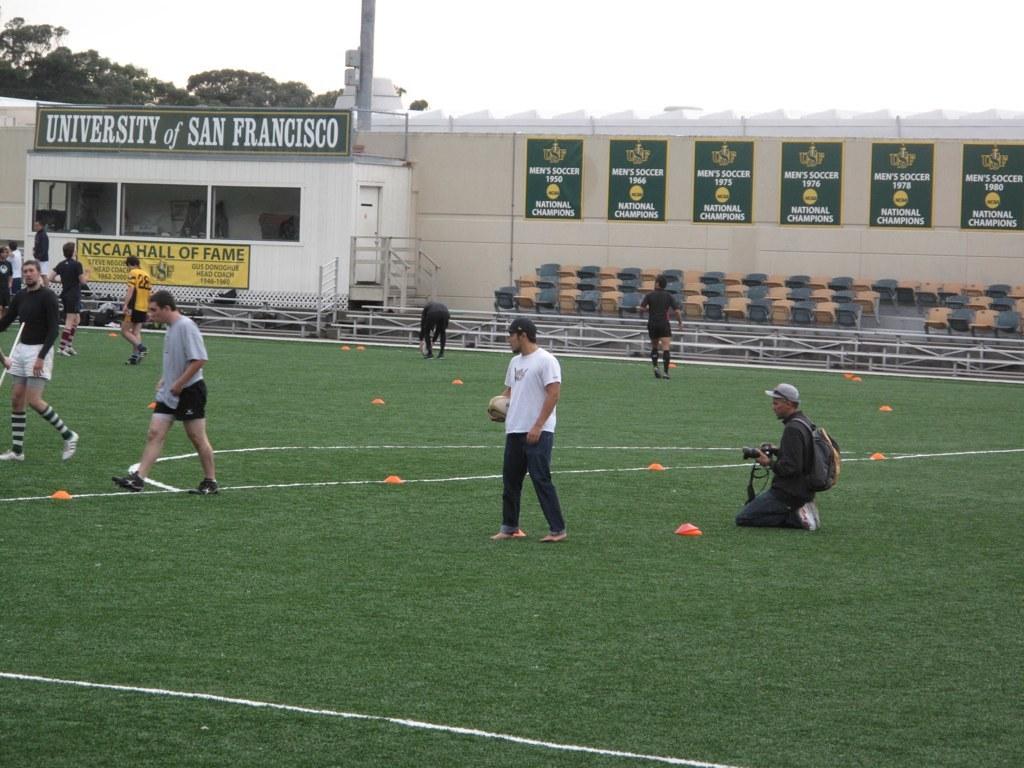What school is this field a part of?
Give a very brief answer. University of san francisco. In what city is this university field located?
Your answer should be compact. San francisco. 